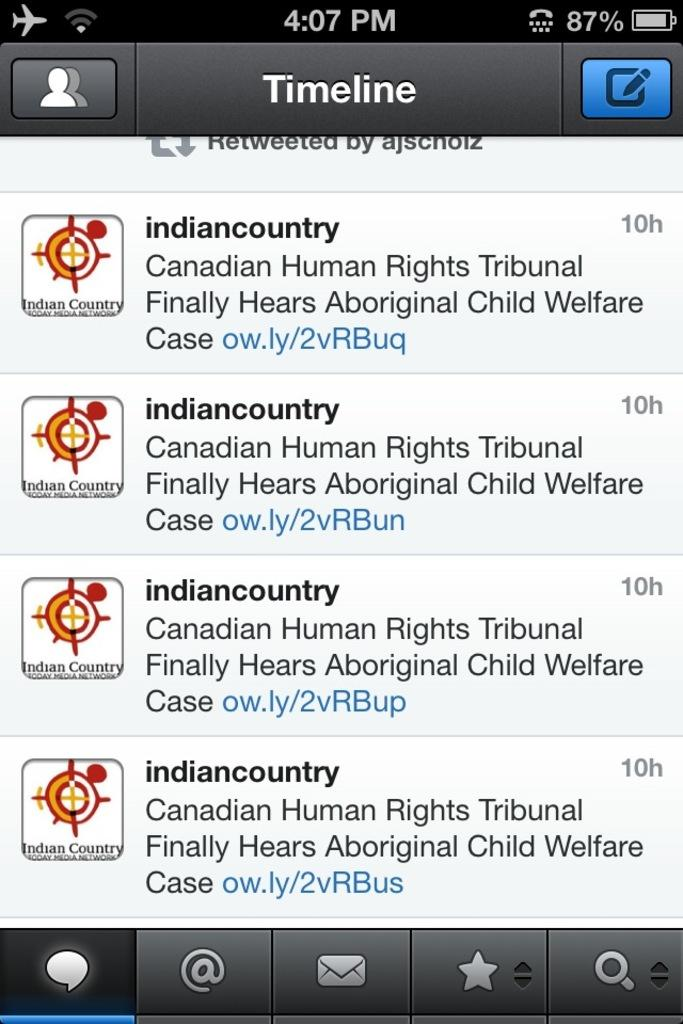<image>
Provide a brief description of the given image. Ten hours ago indiancountry published an article titled, "Canadian Human Rights Tribunal Finally Hears Aboriginal Child Welfare Case". 